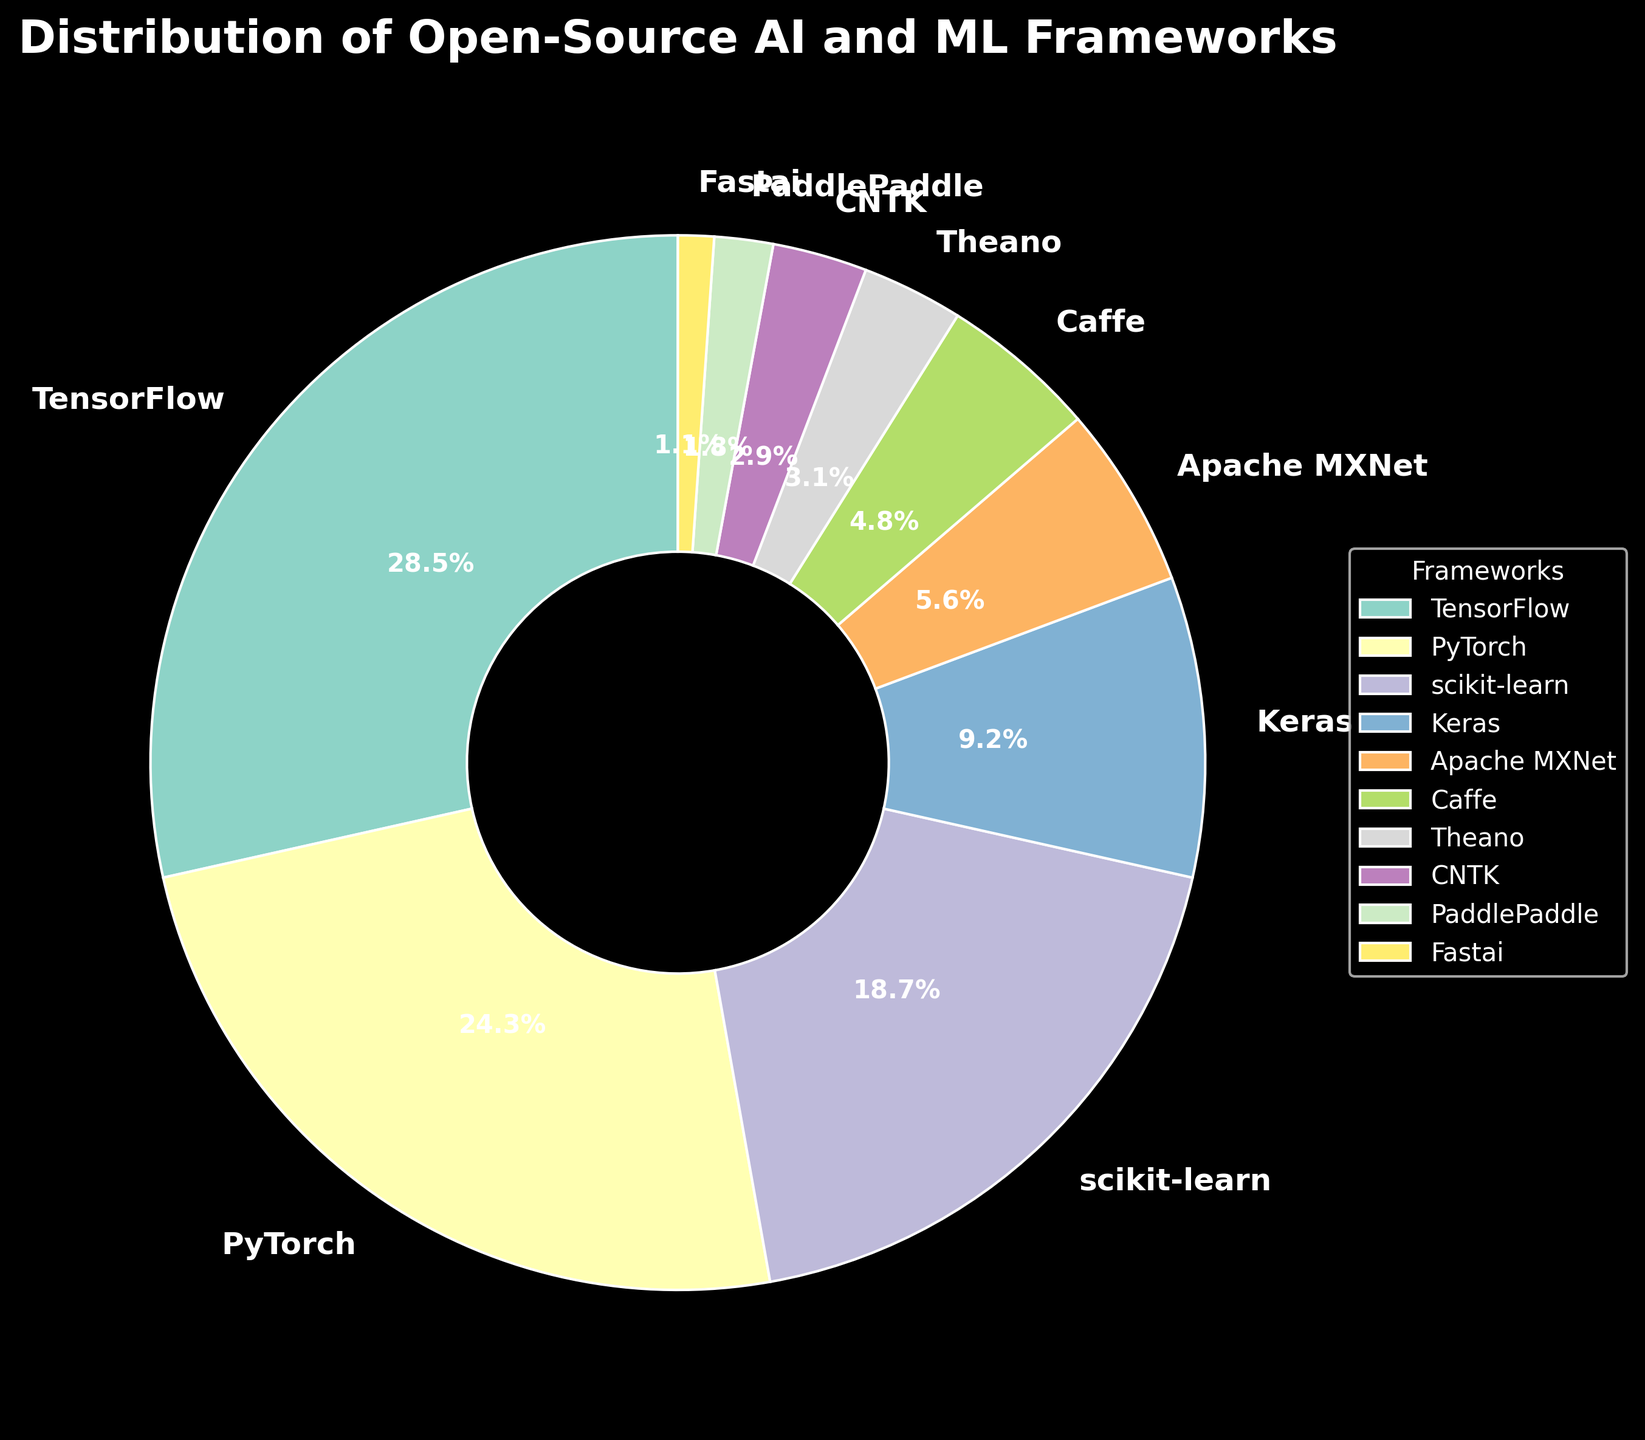What is the most popular open-source AI and ML framework among developers? The most popular framework can be identified by looking at the segment with the largest percentage. The largest segment in the pie chart corresponds to TensorFlow, which has a 28.5% share.
Answer: TensorFlow Which framework has a slightly higher percentage of popularity, PyTorch or scikit-learn? To determine which framework has a slightly higher percentage, compare the percentages directly. PyTorch has a 24.3% share, while scikit-learn has an 18.7% share.
Answer: PyTorch What is the total percentage of developers using either Keras or Apache MXNet? Add the percentages for Keras and Apache MXNet. Keras has 9.2% and Apache MXNet has 5.6%. Thus, the total is 9.2 + 5.6 = 14.8%.
Answer: 14.8% What is the percentage difference between Caffe and Theano? Subtract the percentage of Theano from the percentage of Caffe. Caffe has 4.8% and Theano has 3.1%, so the difference is 4.8 - 3.1 = 1.7%.
Answer: 1.7% Which frameworks combined have a smaller market share than TensorFlow alone? Compare the percentage of TensorFlow (28.5%) with the combined percentages of smaller frameworks. Adding the percentages of CNTK (2.9%), PaddlePaddle (1.8%), and Fastai (1.1%) gives a combined total of 2.9 + 1.8 + 1.1 = 5.8%, which is less than 28.5%.
Answer: CNTK, PaddlePaddle, Fastai Are there any frameworks in the chart with a market share below 2%? Identify the frameworks with percentages below 2%. Both PaddlePaddle (1.8%) and Fastai (1.1%) fall into this category.
Answer: PaddlePaddle, Fastai Which framework has the least popularity according to the chart? The framework with the smallest segment in the pie chart indicates the least popularity. Fastai, with 1.1%, is the smallest segment.
Answer: Fastai What are the middle (median) values of the framework popularity percentages? For an odd number of values, the median is the middle value when sorted. The middle value in sorted order (1.1, 1.8, 2.9, 3.1, 4.8, 5.6, 9.2, 18.7, 24.3, 28.5) is 4.8 (Caffe).
Answer: 4.8 What is the combined percentage of the top three most popular frameworks? Add the percentages of the top three frameworks: TensorFlow (28.5%), PyTorch (24.3%), and scikit-learn (18.7%). The combined percentage is 28.5 + 24.3 + 18.7 = 71.5%.
Answer: 71.5% What color blocks represent TensorFlow and PyTorch in the pie chart? Although exact colors used can't be determined from typical natural descriptions, the color for each framework segment in the pie chart is distinct and can be distinguished visually. TensorFlow and PyTorch would have different colors as per the color palette used in the chart.
Answer: Distinct colors 